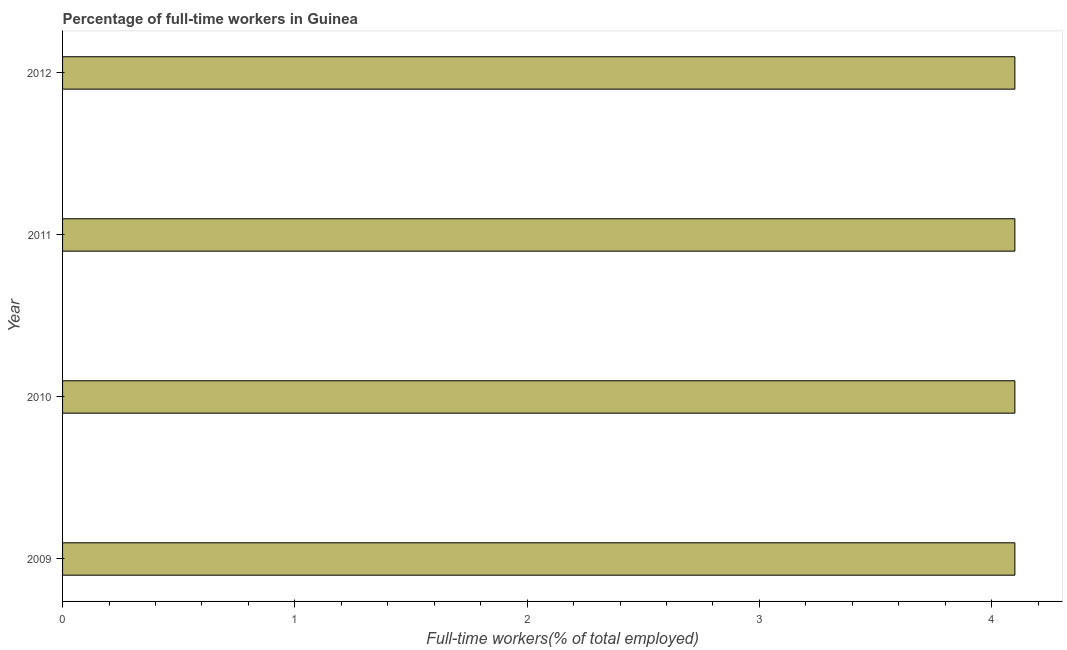Does the graph contain grids?
Offer a very short reply. No. What is the title of the graph?
Offer a very short reply. Percentage of full-time workers in Guinea. What is the label or title of the X-axis?
Ensure brevity in your answer.  Full-time workers(% of total employed). What is the percentage of full-time workers in 2012?
Make the answer very short. 4.1. Across all years, what is the maximum percentage of full-time workers?
Your answer should be compact. 4.1. Across all years, what is the minimum percentage of full-time workers?
Your answer should be compact. 4.1. What is the sum of the percentage of full-time workers?
Your answer should be compact. 16.4. What is the difference between the percentage of full-time workers in 2010 and 2012?
Your response must be concise. 0. What is the average percentage of full-time workers per year?
Your response must be concise. 4.1. What is the median percentage of full-time workers?
Provide a short and direct response. 4.1. In how many years, is the percentage of full-time workers greater than 0.4 %?
Your answer should be very brief. 4. Do a majority of the years between 2009 and 2012 (inclusive) have percentage of full-time workers greater than 3 %?
Your answer should be compact. Yes. Is the sum of the percentage of full-time workers in 2009 and 2010 greater than the maximum percentage of full-time workers across all years?
Give a very brief answer. Yes. In how many years, is the percentage of full-time workers greater than the average percentage of full-time workers taken over all years?
Ensure brevity in your answer.  0. Are the values on the major ticks of X-axis written in scientific E-notation?
Provide a short and direct response. No. What is the Full-time workers(% of total employed) in 2009?
Provide a short and direct response. 4.1. What is the Full-time workers(% of total employed) of 2010?
Provide a succinct answer. 4.1. What is the Full-time workers(% of total employed) in 2011?
Offer a very short reply. 4.1. What is the Full-time workers(% of total employed) of 2012?
Give a very brief answer. 4.1. What is the difference between the Full-time workers(% of total employed) in 2009 and 2011?
Provide a succinct answer. 0. What is the ratio of the Full-time workers(% of total employed) in 2010 to that in 2011?
Provide a succinct answer. 1. What is the ratio of the Full-time workers(% of total employed) in 2010 to that in 2012?
Offer a terse response. 1. What is the ratio of the Full-time workers(% of total employed) in 2011 to that in 2012?
Provide a succinct answer. 1. 